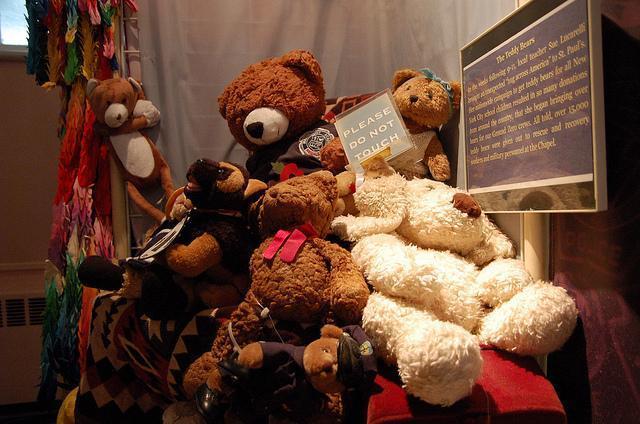How many rows of bears are visible?
Give a very brief answer. 2. How many teddy bears are there?
Give a very brief answer. 7. How many boys are wearing hats?
Give a very brief answer. 0. 